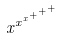Convert formula to latex. <formula><loc_0><loc_0><loc_500><loc_500>x ^ { x ^ { x ^ { + ^ { + ^ { + } } } } }</formula> 